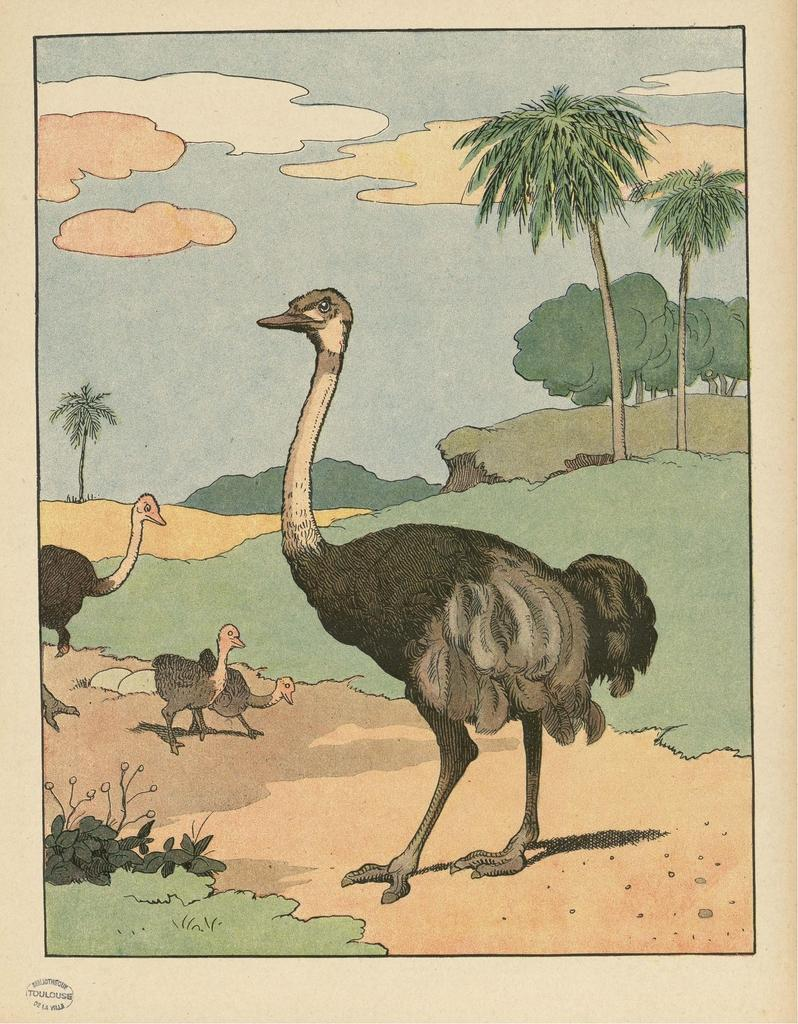What type of animals can be seen in the image? There are birds in the image. What type of vegetation is present in the image? There are plants, trees, and grass in the image. What can be seen in the sky in the image? There are clouds in the sky in the image. Is there any text visible in the image? Yes, there is text visible in the image. What can be found in the bottom left of the image? There are a few things in the bottom left of the image. What type of cord is being used by the birds to grow bananas in the image? There is no cord or bananas present in the image; it features birds, plants, trees, grass, clouds, text, and objects in the bottom left corner. 